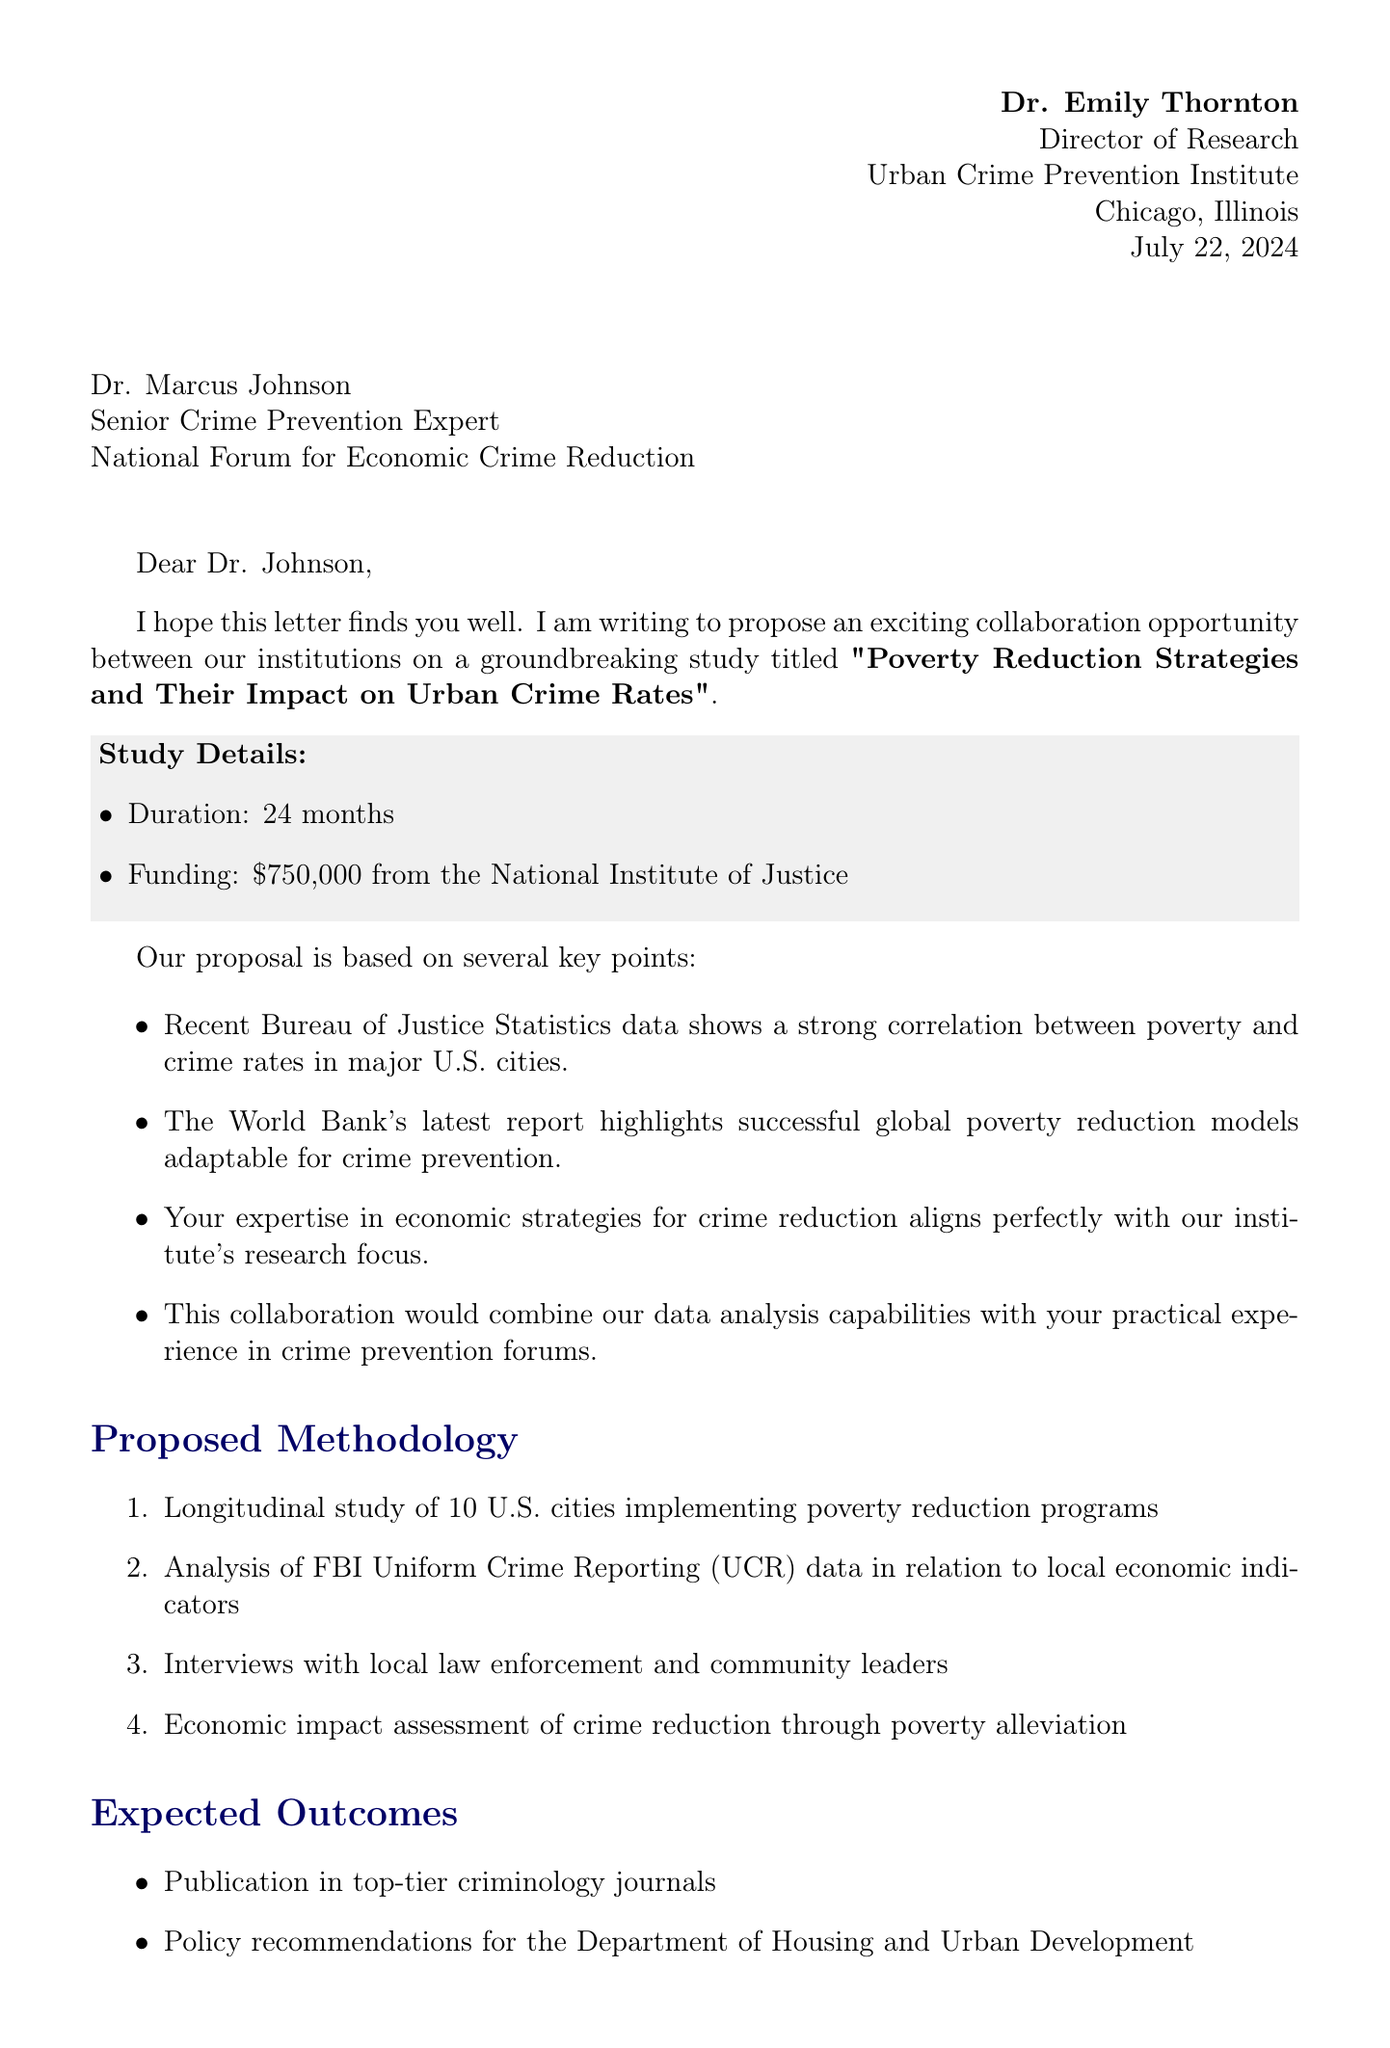What is the title of the proposed study? The title of the study is provided in the document as the collaboration proposal's name.
Answer: Poverty Reduction Strategies and Their Impact on Urban Crime Rates Who is the sender of the letter? The document provides the name and title of the person sending the letter, which is essential information.
Answer: Dr. Emily Thornton What is the total duration of the proposed study? The duration of the study is specifically mentioned in the proposal section of the document.
Answer: 24 months What is the funding amount for the study? The funding amount is clearly stated in the study details section of the letter.
Answer: $750,000 Which organization is funding the study? The document specifies the funding source for the proposed study, which is key information.
Answer: National Institute of Justice What is one expected outcome of the study? The expected outcomes section lists several outcomes that are anticipated from the collaboration.
Answer: Publication in top-tier criminology journals What type of study is proposed in the methodology? The methodology section describes the kind of research approach being proposed, which is an important detail.
Answer: Longitudinal study What is a benefit of collaboration mentioned in the letter? The letter outlines several benefits to collaboration, highlighting the advantages of working together.
Answer: Access to Urban Crime Prevention Institute's extensive database and analytics tools What is the next step suggested in the document? The letter outlines the proposed next steps, which are critical for moving forward with the collaboration.
Answer: Schedule a video conference to discuss the proposal in detail 